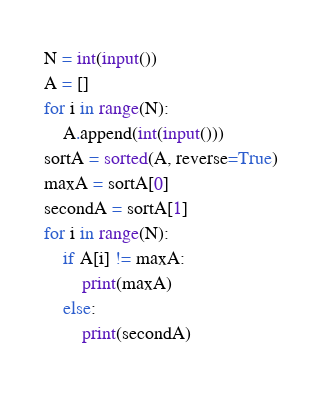Convert code to text. <code><loc_0><loc_0><loc_500><loc_500><_Python_>N = int(input())
A = []
for i in range(N):
    A.append(int(input()))
sortA = sorted(A, reverse=True)
maxA = sortA[0]
secondA = sortA[1]
for i in range(N):
    if A[i] != maxA:
        print(maxA)
    else:
        print(secondA)
        </code> 